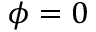<formula> <loc_0><loc_0><loc_500><loc_500>\phi = 0</formula> 